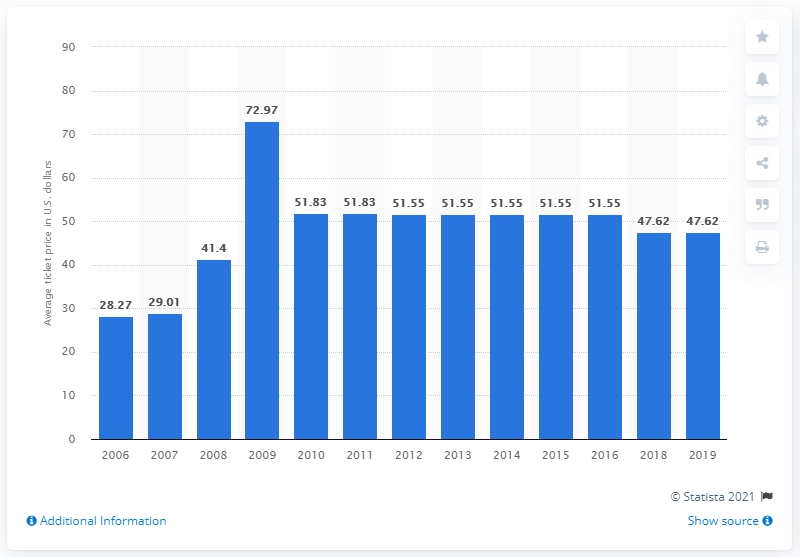Point out several critical features in this image. The average ticket price for New York Yankees games in 2019 was $47.62. 